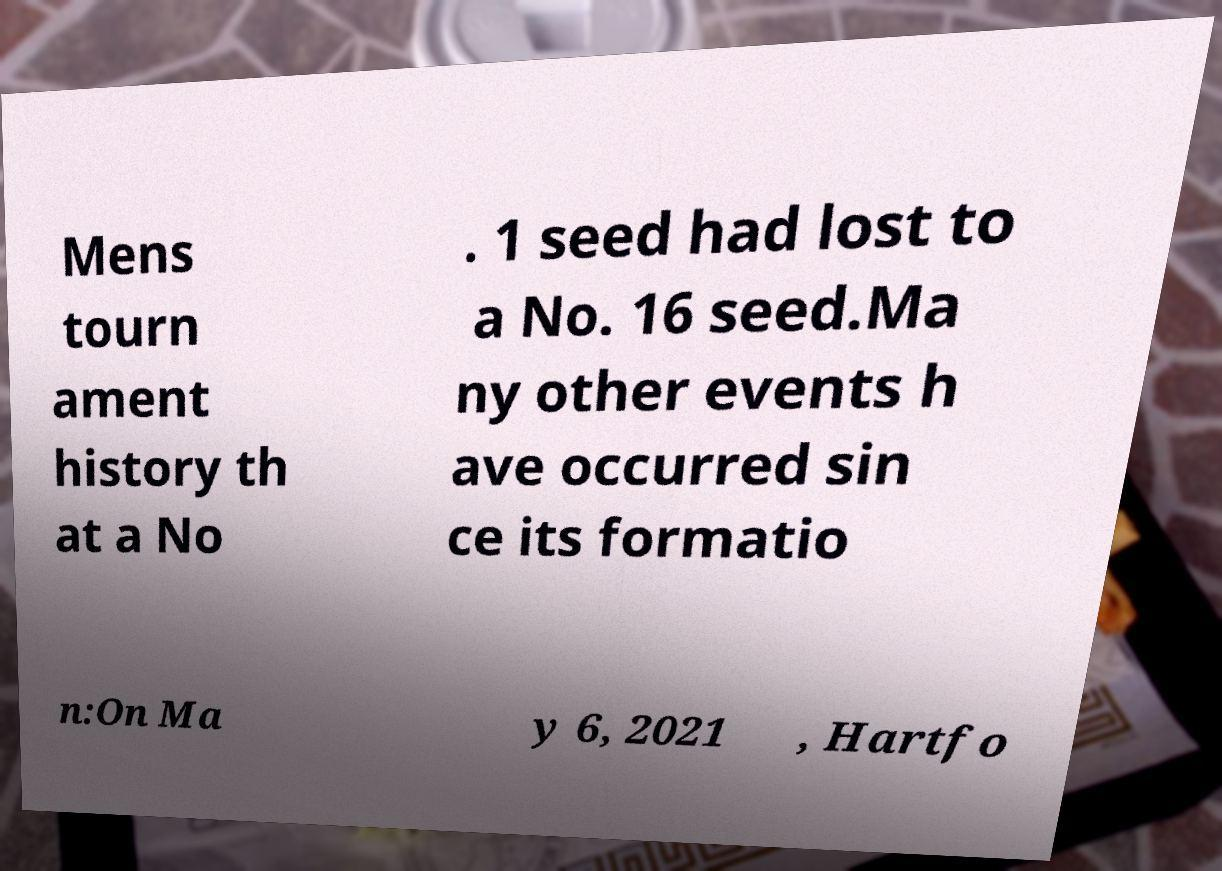Can you accurately transcribe the text from the provided image for me? Mens tourn ament history th at a No . 1 seed had lost to a No. 16 seed.Ma ny other events h ave occurred sin ce its formatio n:On Ma y 6, 2021 , Hartfo 